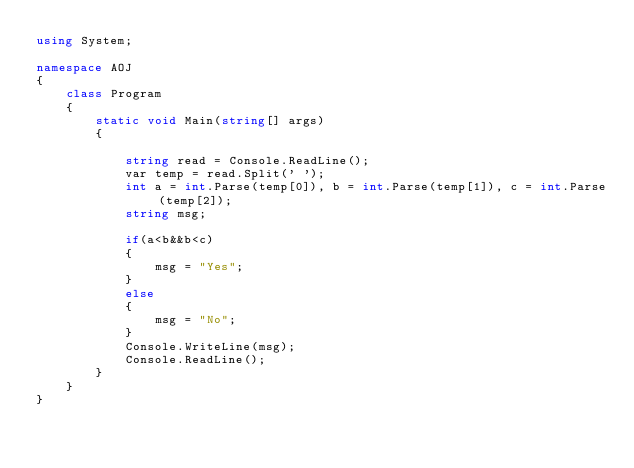<code> <loc_0><loc_0><loc_500><loc_500><_C#_>using System;

namespace AOJ
{
    class Program
    {
        static void Main(string[] args)
        {

            string read = Console.ReadLine();
            var temp = read.Split(' ');
            int a = int.Parse(temp[0]), b = int.Parse(temp[1]), c = int.Parse(temp[2]);
            string msg;

            if(a<b&&b<c)
            {
                msg = "Yes";
            }
            else
            {
                msg = "No";
            }
            Console.WriteLine(msg);
            Console.ReadLine();
        }
    }
}</code> 